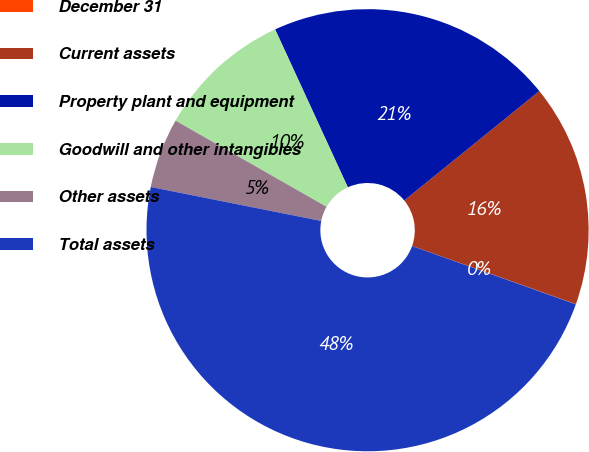Convert chart. <chart><loc_0><loc_0><loc_500><loc_500><pie_chart><fcel>December 31<fcel>Current assets<fcel>Property plant and equipment<fcel>Goodwill and other intangibles<fcel>Other assets<fcel>Total assets<nl><fcel>0.02%<fcel>16.26%<fcel>21.03%<fcel>9.88%<fcel>5.12%<fcel>47.69%<nl></chart> 